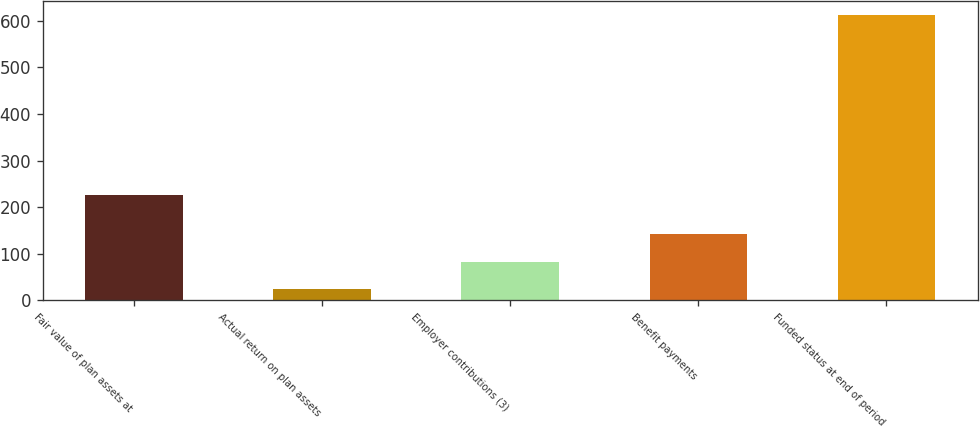<chart> <loc_0><loc_0><loc_500><loc_500><bar_chart><fcel>Fair value of plan assets at<fcel>Actual return on plan assets<fcel>Employer contributions (3)<fcel>Benefit payments<fcel>Funded status at end of period<nl><fcel>225<fcel>24<fcel>82.8<fcel>141.6<fcel>612<nl></chart> 